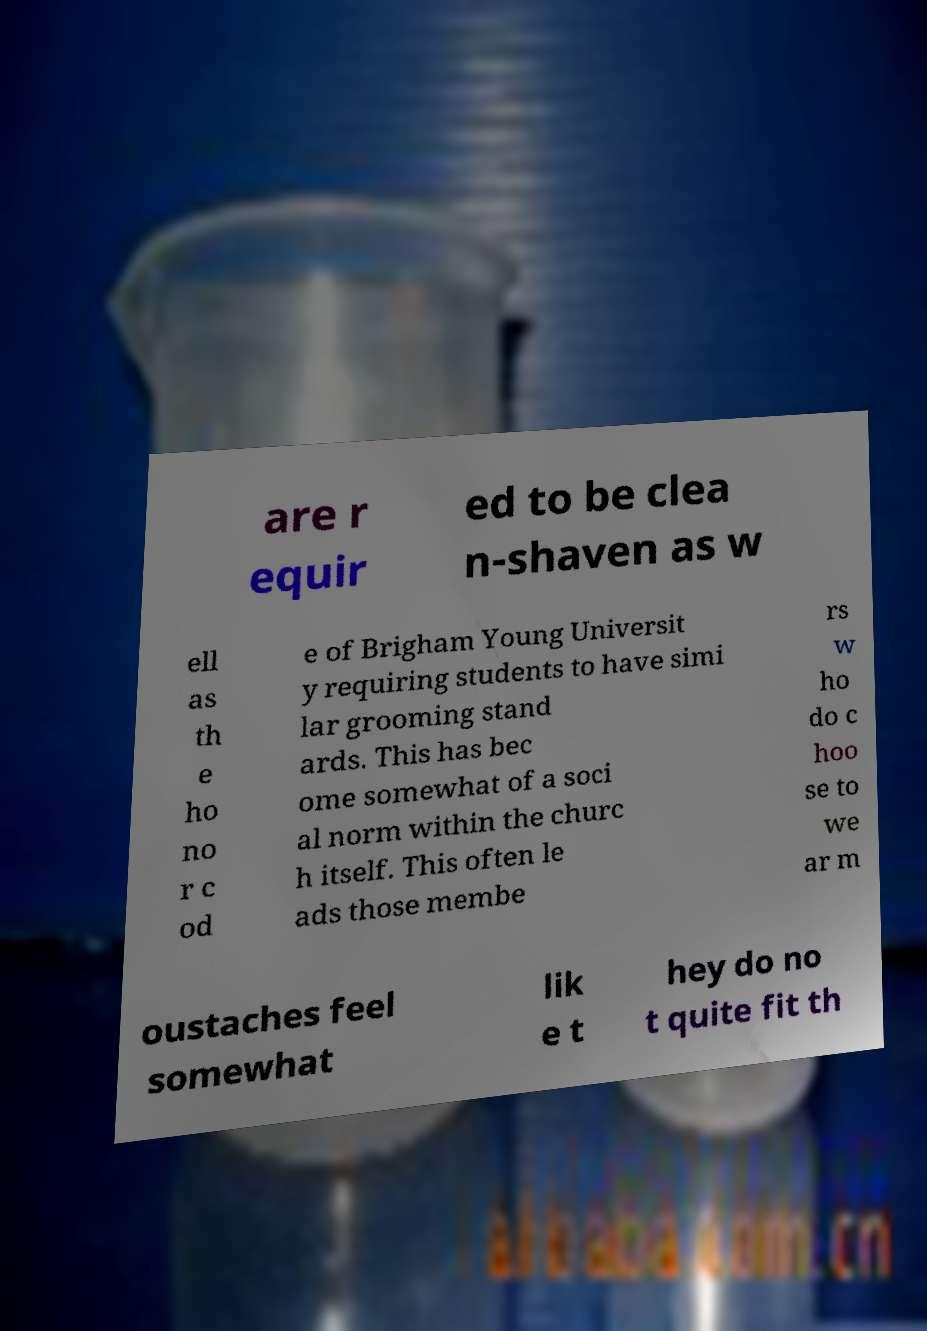Could you assist in decoding the text presented in this image and type it out clearly? are r equir ed to be clea n-shaven as w ell as th e ho no r c od e of Brigham Young Universit y requiring students to have simi lar grooming stand ards. This has bec ome somewhat of a soci al norm within the churc h itself. This often le ads those membe rs w ho do c hoo se to we ar m oustaches feel somewhat lik e t hey do no t quite fit th 